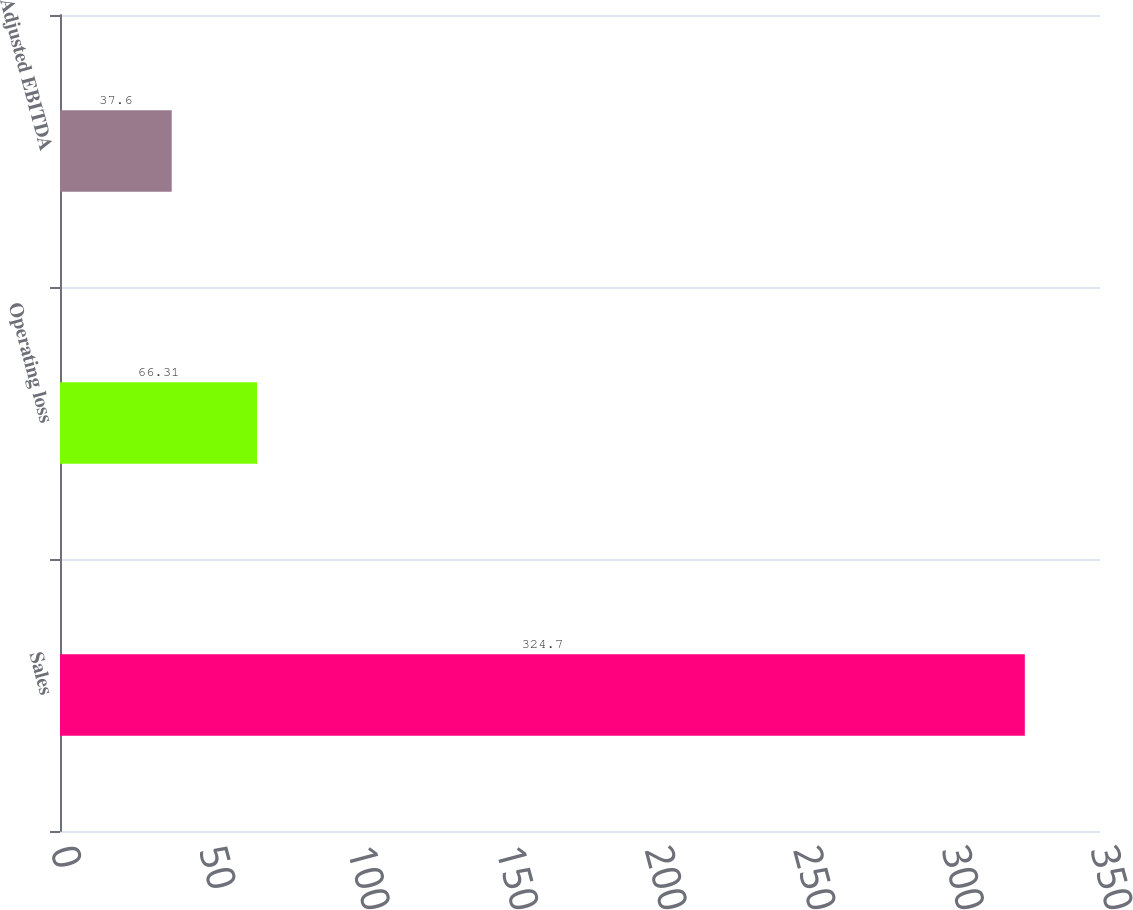<chart> <loc_0><loc_0><loc_500><loc_500><bar_chart><fcel>Sales<fcel>Operating loss<fcel>Adjusted EBITDA<nl><fcel>324.7<fcel>66.31<fcel>37.6<nl></chart> 